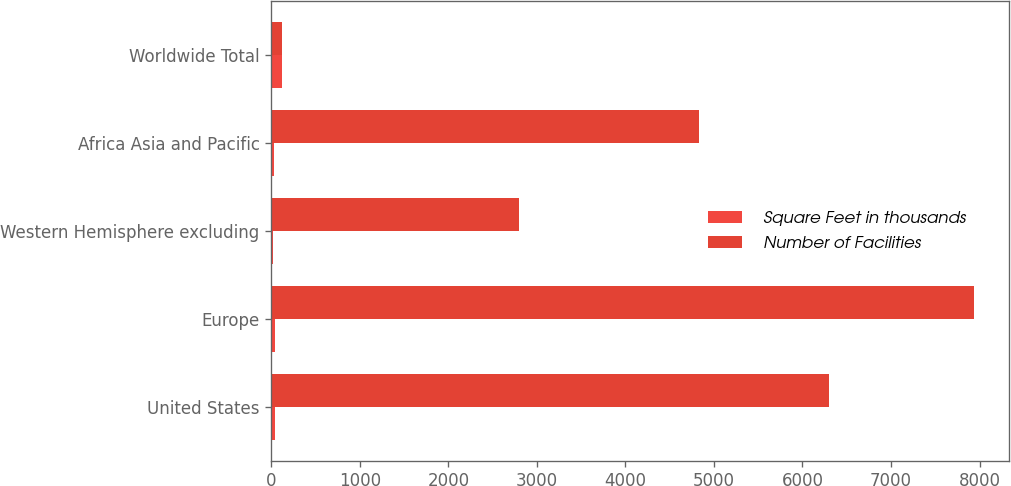<chart> <loc_0><loc_0><loc_500><loc_500><stacked_bar_chart><ecel><fcel>United States<fcel>Europe<fcel>Western Hemisphere excluding<fcel>Africa Asia and Pacific<fcel>Worldwide Total<nl><fcel>Square Feet in thousands<fcel>40<fcel>37<fcel>14<fcel>34<fcel>125<nl><fcel>Number of Facilities<fcel>6300<fcel>7939<fcel>2800<fcel>4834<fcel>125<nl></chart> 